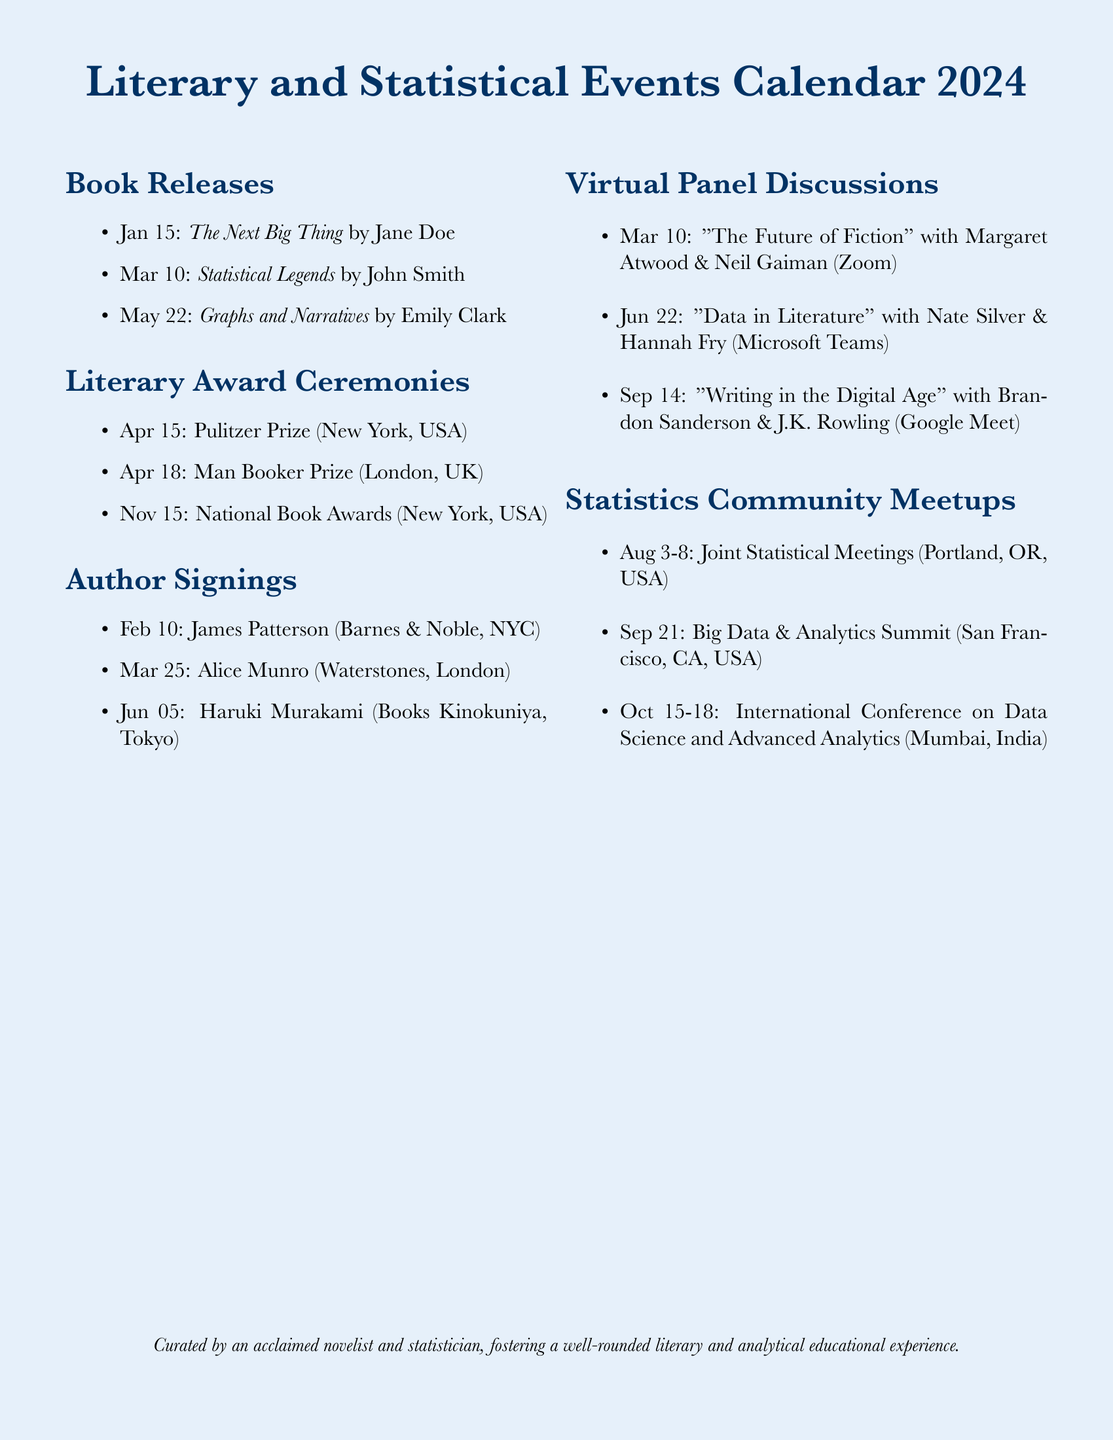What is the release date of "The Next Big Thing"? The release date can be found in the Book Releases section of the document, which states it is on January 15.
Answer: January 15 Who is signing books on February 10? The Author Signings section shows that James Patterson will be signing books on this date.
Answer: James Patterson What is the name of the panel discussion featuring Nate Silver? The Virtual Panel Discussions section lists "Data in Literature" with Nate Silver on June 22.
Answer: Data in Literature When is the Pulitzer Prize ceremony? The Literary Award Ceremonies section states that the Pulitzer Prize is on April 15.
Answer: April 15 How many days are the Joint Statistical Meetings scheduled for? This event is from August 3 to August 8, which is 6 days in total.
Answer: 6 days Which author will have a signing at Waterstones? The document specifies that Alice Munro will be signing books at Waterstones on March 25.
Answer: Alice Munro Which city will host the International Conference on Data Science and Advanced Analytics? The Statistics Community Meetups section indicates that this conference will take place in Mumbai.
Answer: Mumbai What date is "Graphs and Narratives" released? The Book Releases section notes that this book is set to be released on May 22.
Answer: May 22 Who are the authors participating in the panel discussion on March 10? The Virtual Panel Discussions section shows that Margaret Atwood and Neil Gaiman are the authors for this event.
Answer: Margaret Atwood and Neil Gaiman 